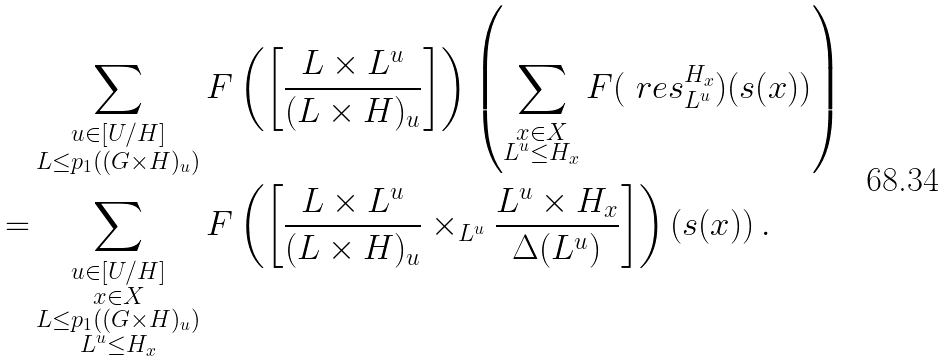<formula> <loc_0><loc_0><loc_500><loc_500>& \sum _ { \substack { u \in [ U / H ] \\ L \leq p _ { 1 } ( ( G \times H ) _ { u } ) } } F \left ( \left [ \frac { L \times L ^ { u } } { ( L \times H ) _ { u } } \right ] \right ) \left ( \sum _ { \substack { x \in X \\ L ^ { u } \leq H _ { x } } } F ( \ r e s ^ { H _ { x } } _ { L ^ { u } } ) ( s ( x ) ) \right ) \\ = & \sum _ { \substack { u \in [ U / H ] \\ x \in X \\ L \leq p _ { 1 } ( ( G \times H ) _ { u } ) \\ L ^ { u } \leq H _ { x } } } F \left ( \left [ \frac { L \times L ^ { u } } { ( L \times H ) _ { u } } \times _ { L ^ { u } } \frac { L ^ { u } \times H _ { x } } { \Delta ( L ^ { u } ) } \right ] \right ) ( s ( x ) ) \, .</formula> 